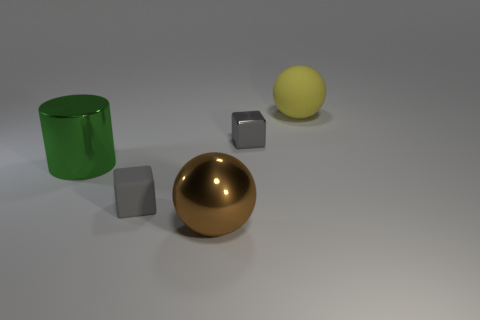Add 3 large shiny cylinders. How many objects exist? 8 Subtract all cubes. How many objects are left? 3 Add 2 tiny yellow objects. How many tiny yellow objects exist? 2 Subtract 0 gray spheres. How many objects are left? 5 Subtract all large yellow cylinders. Subtract all large matte balls. How many objects are left? 4 Add 3 tiny gray things. How many tiny gray things are left? 5 